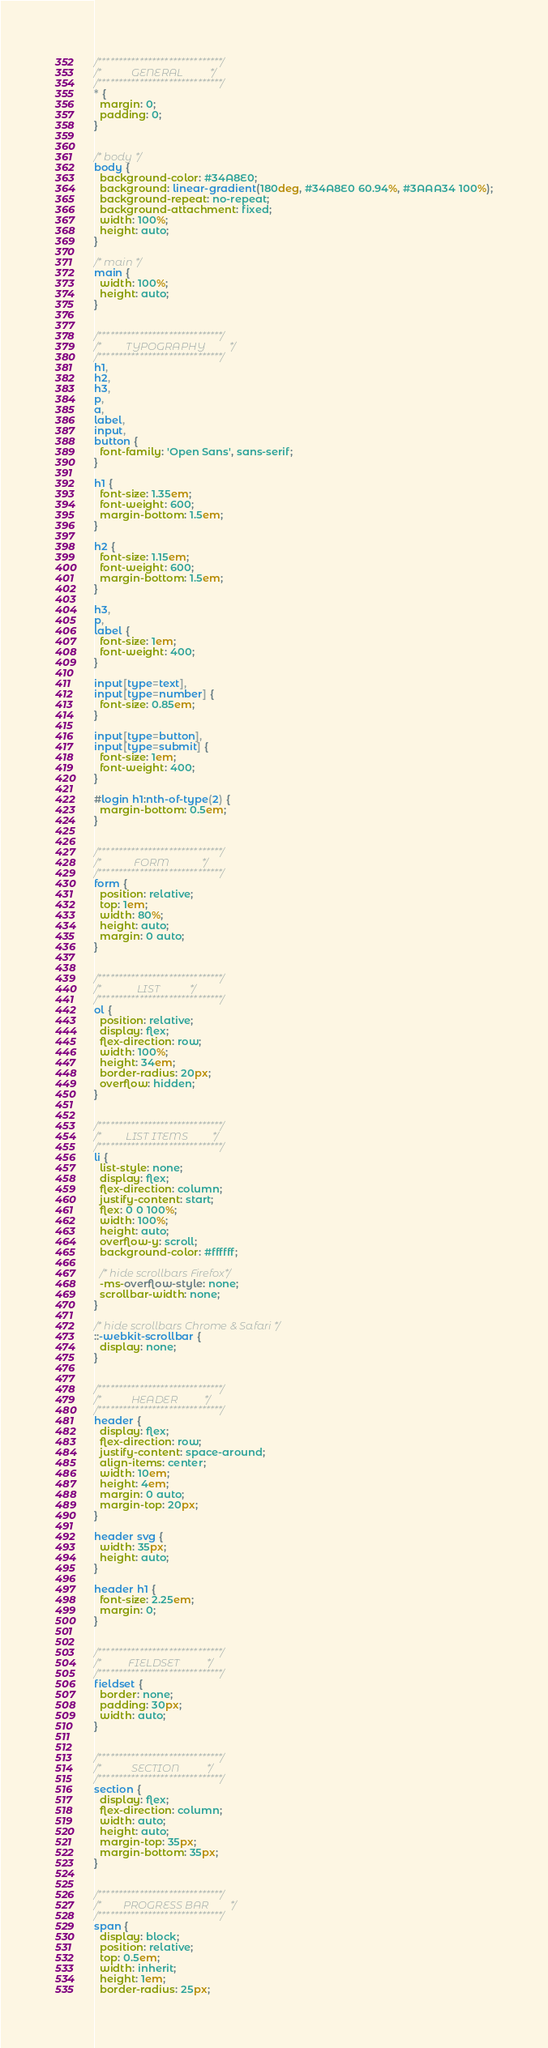Convert code to text. <code><loc_0><loc_0><loc_500><loc_500><_CSS_>/******************************/
/*           GENERAL          */
/******************************/
* {
  margin: 0;
  padding: 0;
}


/* body */
body {
  background-color: #34A8E0;
  background: linear-gradient(180deg, #34A8E0 60.94%, #3AAA34 100%);
  background-repeat: no-repeat;
  background-attachment: fixed;
  width: 100%;
  height: auto;
}

/* main */
main {
  width: 100%;
  height: auto;
}


/******************************/
/*         TYPOGRAPHY         */
/******************************/
h1,
h2,
h3,
p,
a,
label,
input,
button {
  font-family: 'Open Sans', sans-serif;
}

h1 {
  font-size: 1.35em;
  font-weight: 600;
  margin-bottom: 1.5em;
}

h2 {
  font-size: 1.15em;
  font-weight: 600;
  margin-bottom: 1.5em;
}

h3,
p,
label {
  font-size: 1em;
  font-weight: 400;
}

input[type=text],
input[type=number] {
  font-size: 0.85em;
}

input[type=button],
input[type=submit] {
  font-size: 1em;
  font-weight: 400;
}

#login h1:nth-of-type(2) {
  margin-bottom: 0.5em;
}


/******************************/
/*            FORM            */
/******************************/
form {
  position: relative;
  top: 1em;
  width: 80%;
  height: auto;
  margin: 0 auto;
}


/******************************/
/*             LIST           */
/******************************/
ol {
  position: relative;
  display: flex;
  flex-direction: row;
  width: 100%;
  height: 34em;
  border-radius: 20px;
  overflow: hidden;
}


/******************************/
/*         LIST ITEMS         */
/******************************/
li {
  list-style: none;
  display: flex;
  flex-direction: column;
  justify-content: start;
  flex: 0 0 100%;
  width: 100%;
  height: auto;
  overflow-y: scroll;
  background-color: #ffffff;

  /* hide scrollbars Firefox*/
  -ms-overflow-style: none;
  scrollbar-width: none;
}

/* hide scrollbars Chrome & Safari */
::-webkit-scrollbar {
  display: none;
}


/******************************/
/*           HEADER          */
/******************************/
header {
  display: flex;
  flex-direction: row;
  justify-content: space-around;
  align-items: center;
  width: 10em;
  height: 4em;
  margin: 0 auto;
  margin-top: 20px;
}

header svg {
  width: 35px;
  height: auto;
}

header h1 {
  font-size: 2.25em;
  margin: 0;
}


/******************************/
/*          FIELDSET          */
/******************************/
fieldset {
  border: none;
  padding: 30px;
  width: auto;
}


/******************************/
/*           SECTION          */
/******************************/
section {
  display: flex;
  flex-direction: column;
  width: auto;
  height: auto;
  margin-top: 35px;
  margin-bottom: 35px;
}


/******************************/
/*        PROGRESS BAR        */
/******************************/
span {
  display: block;
  position: relative;
  top: 0.5em;
  width: inherit;
  height: 1em;
  border-radius: 25px;</code> 